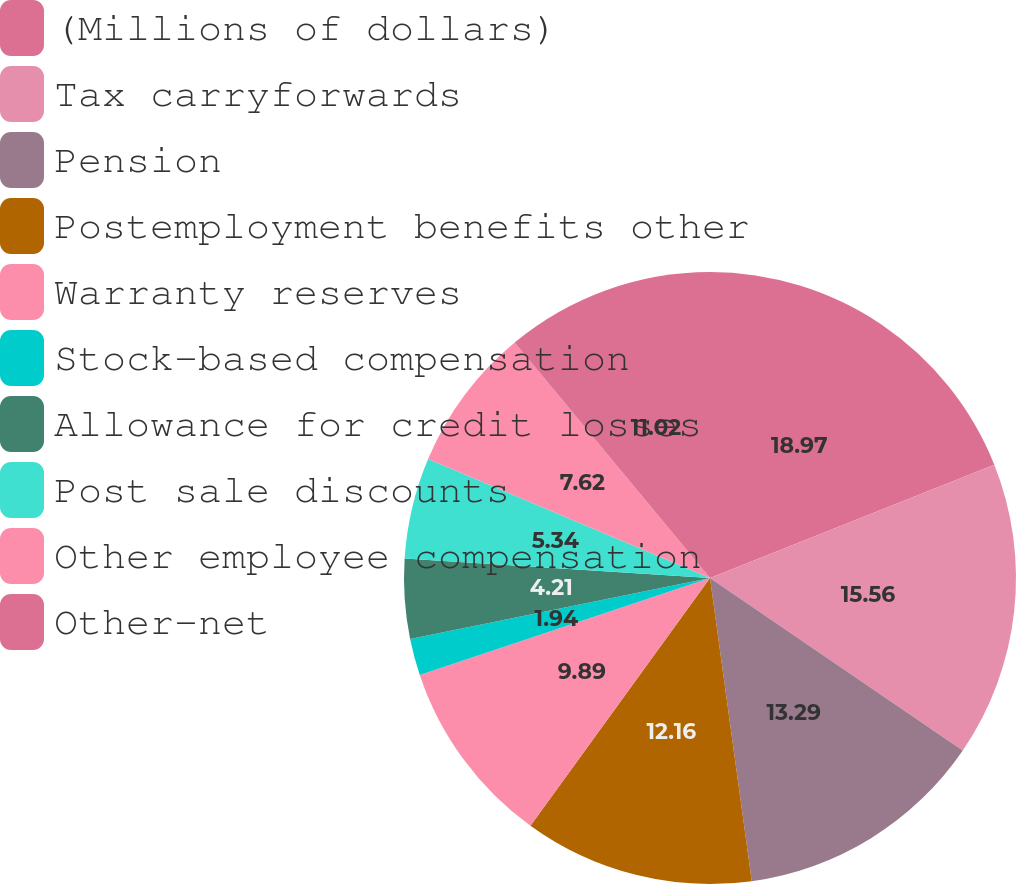<chart> <loc_0><loc_0><loc_500><loc_500><pie_chart><fcel>(Millions of dollars)<fcel>Tax carryforwards<fcel>Pension<fcel>Postemployment benefits other<fcel>Warranty reserves<fcel>Stock-based compensation<fcel>Allowance for credit losses<fcel>Post sale discounts<fcel>Other employee compensation<fcel>Other-net<nl><fcel>18.97%<fcel>15.56%<fcel>13.29%<fcel>12.16%<fcel>9.89%<fcel>1.94%<fcel>4.21%<fcel>5.34%<fcel>7.62%<fcel>11.02%<nl></chart> 